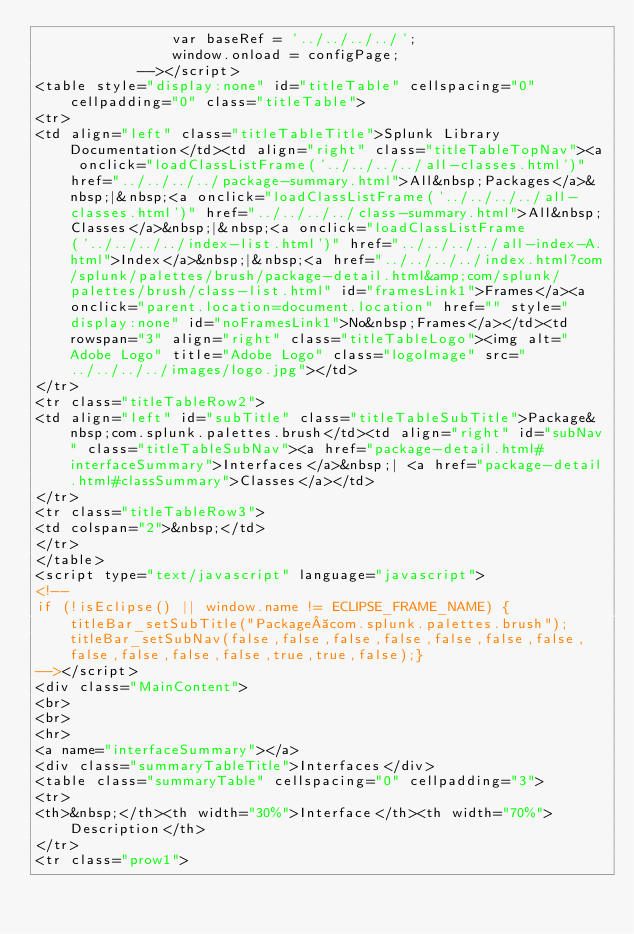Convert code to text. <code><loc_0><loc_0><loc_500><loc_500><_HTML_>				var baseRef = '../../../../';
				window.onload = configPage;
			--></script>
<table style="display:none" id="titleTable" cellspacing="0" cellpadding="0" class="titleTable">
<tr>
<td align="left" class="titleTableTitle">Splunk Library Documentation</td><td align="right" class="titleTableTopNav"><a onclick="loadClassListFrame('../../../../all-classes.html')" href="../../../../package-summary.html">All&nbsp;Packages</a>&nbsp;|&nbsp;<a onclick="loadClassListFrame('../../../../all-classes.html')" href="../../../../class-summary.html">All&nbsp;Classes</a>&nbsp;|&nbsp;<a onclick="loadClassListFrame('../../../../index-list.html')" href="../../../../all-index-A.html">Index</a>&nbsp;|&nbsp;<a href="../../../../index.html?com/splunk/palettes/brush/package-detail.html&amp;com/splunk/palettes/brush/class-list.html" id="framesLink1">Frames</a><a onclick="parent.location=document.location" href="" style="display:none" id="noFramesLink1">No&nbsp;Frames</a></td><td rowspan="3" align="right" class="titleTableLogo"><img alt="Adobe Logo" title="Adobe Logo" class="logoImage" src="../../../../images/logo.jpg"></td>
</tr>
<tr class="titleTableRow2">
<td align="left" id="subTitle" class="titleTableSubTitle">Package&nbsp;com.splunk.palettes.brush</td><td align="right" id="subNav" class="titleTableSubNav"><a href="package-detail.html#interfaceSummary">Interfaces</a>&nbsp;| <a href="package-detail.html#classSummary">Classes</a></td>
</tr>
<tr class="titleTableRow3">
<td colspan="2">&nbsp;</td>
</tr>
</table>
<script type="text/javascript" language="javascript">
<!--
if (!isEclipse() || window.name != ECLIPSE_FRAME_NAME) {titleBar_setSubTitle("Package com.splunk.palettes.brush"); titleBar_setSubNav(false,false,false,false,false,false,false,false,false,false,false,true,true,false);}
--></script>
<div class="MainContent">
<br>
<br>
<hr>
<a name="interfaceSummary"></a>
<div class="summaryTableTitle">Interfaces</div>
<table class="summaryTable" cellspacing="0" cellpadding="3">
<tr>
<th>&nbsp;</th><th width="30%">Interface</th><th width="70%">Description</th>
</tr>
<tr class="prow1"></code> 